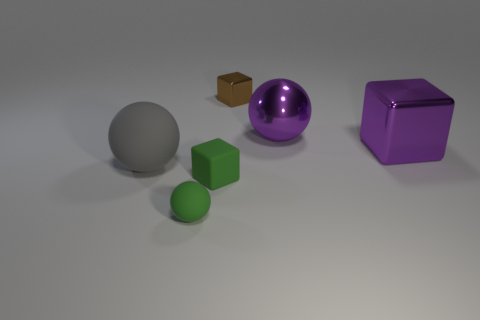Is there any other thing that has the same color as the small sphere?
Offer a terse response. Yes. Is the number of big purple metal spheres in front of the small ball less than the number of big purple things?
Provide a short and direct response. Yes. How many brown blocks have the same size as the gray matte object?
Make the answer very short. 0. What is the shape of the matte thing that is the same color as the tiny rubber cube?
Your answer should be compact. Sphere. What is the shape of the big object left of the small thing left of the tiny block in front of the tiny brown shiny block?
Keep it short and to the point. Sphere. There is a large object that is on the left side of the brown metallic thing; what color is it?
Provide a short and direct response. Gray. How many things are either tiny objects behind the large matte thing or small green things that are to the left of the small green rubber cube?
Give a very brief answer. 2. What number of other large objects are the same shape as the gray matte thing?
Ensure brevity in your answer.  1. What color is the matte sphere that is the same size as the matte cube?
Keep it short and to the point. Green. What is the color of the thing on the left side of the matte sphere that is to the right of the big thing that is on the left side of the brown shiny object?
Provide a succinct answer. Gray. 